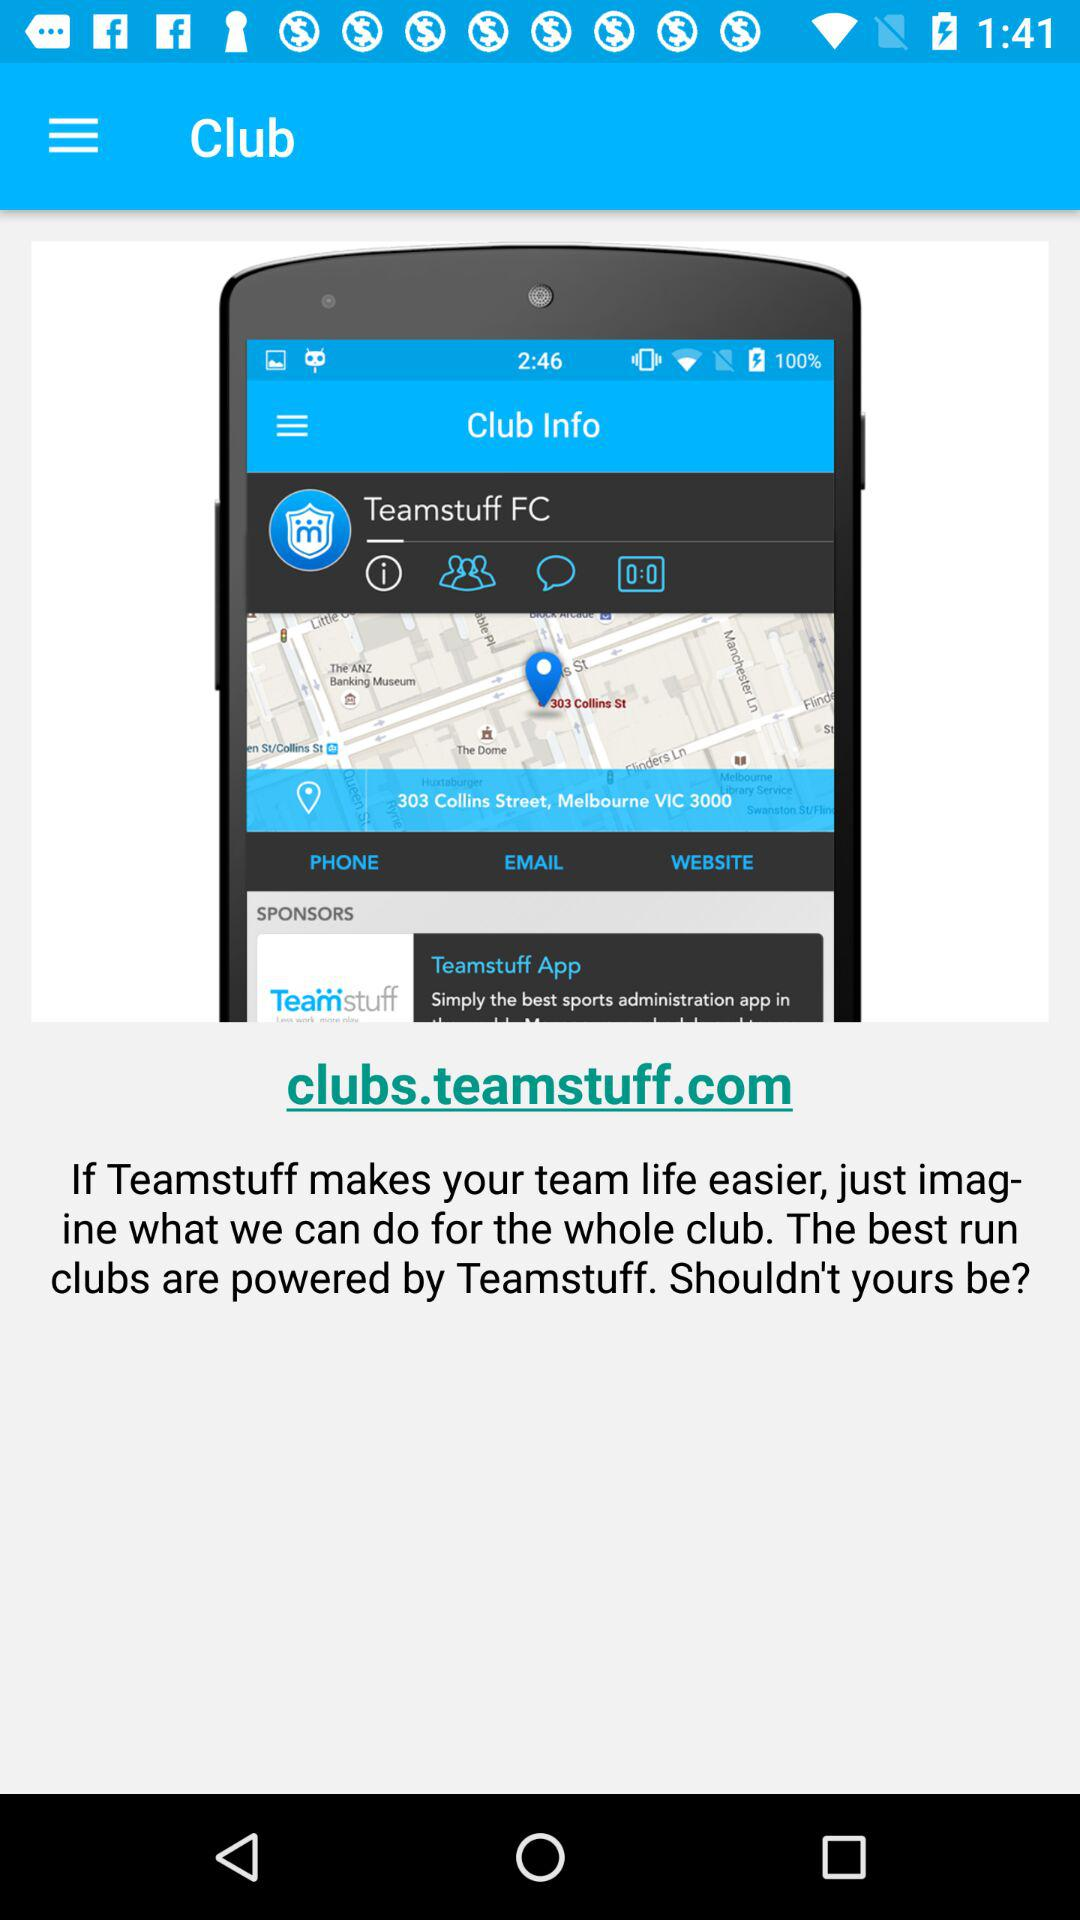What is the location of Teamstuff FC? The location is 303 Collins Street, Melbourne, VIC 3000. 